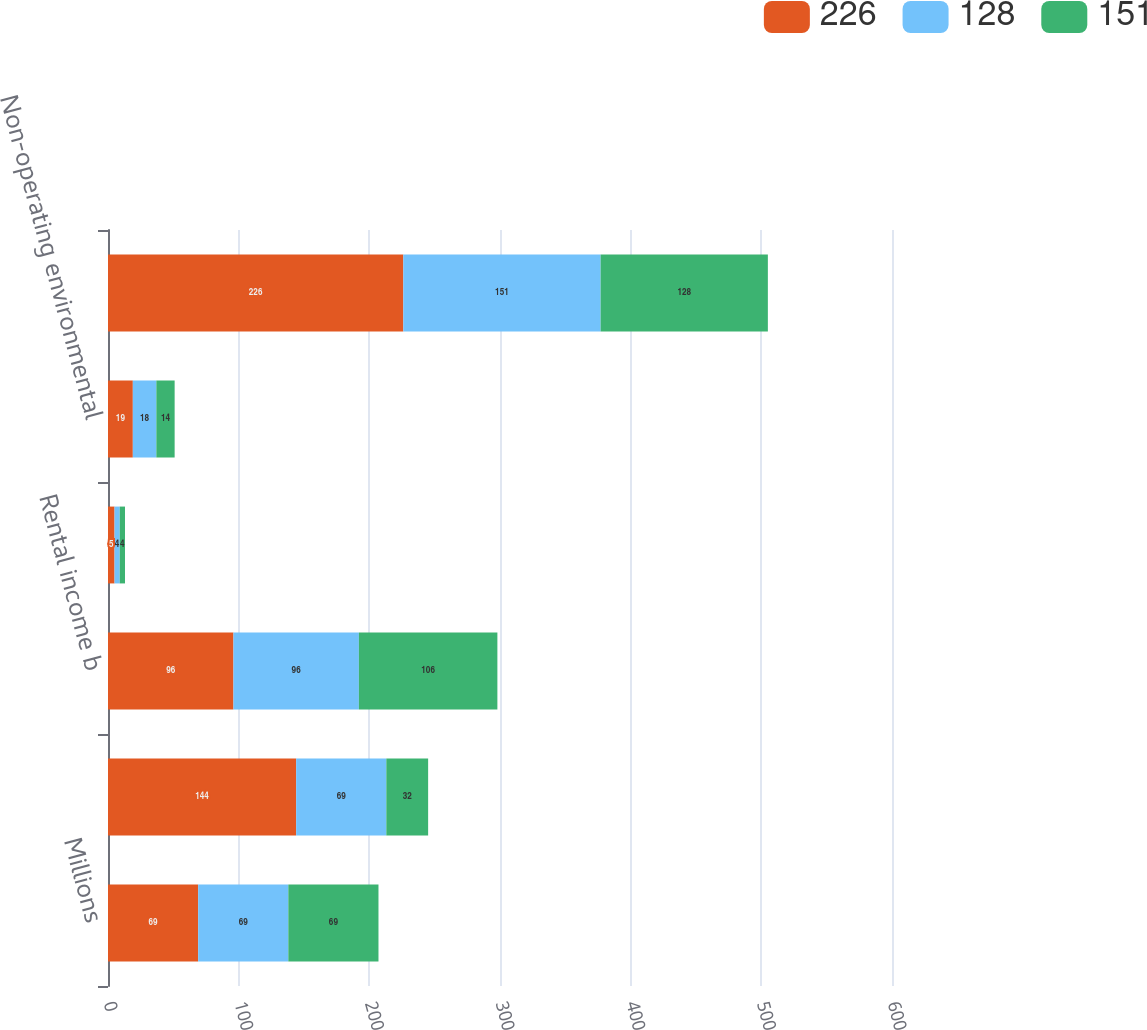Convert chart. <chart><loc_0><loc_0><loc_500><loc_500><stacked_bar_chart><ecel><fcel>Millions<fcel>Net gain on non-operating<fcel>Rental income b<fcel>Interest income<fcel>Non-operating environmental<fcel>Total<nl><fcel>226<fcel>69<fcel>144<fcel>96<fcel>5<fcel>19<fcel>226<nl><fcel>128<fcel>69<fcel>69<fcel>96<fcel>4<fcel>18<fcel>151<nl><fcel>151<fcel>69<fcel>32<fcel>106<fcel>4<fcel>14<fcel>128<nl></chart> 